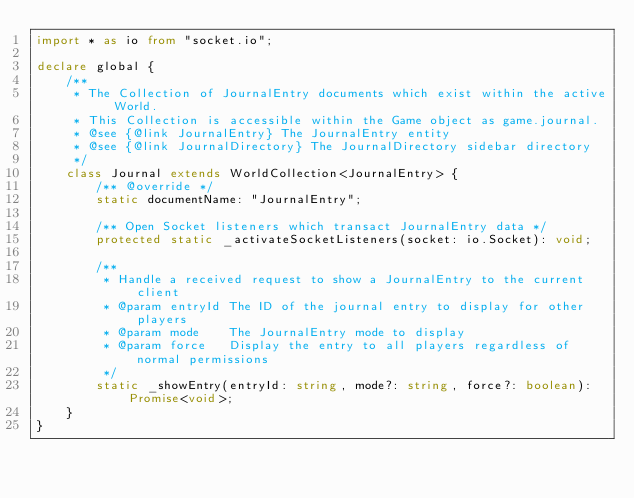<code> <loc_0><loc_0><loc_500><loc_500><_TypeScript_>import * as io from "socket.io";

declare global {
    /**
     * The Collection of JournalEntry documents which exist within the active World.
     * This Collection is accessible within the Game object as game.journal.
     * @see {@link JournalEntry} The JournalEntry entity
     * @see {@link JournalDirectory} The JournalDirectory sidebar directory
     */
    class Journal extends WorldCollection<JournalEntry> {
        /** @override */
        static documentName: "JournalEntry";

        /** Open Socket listeners which transact JournalEntry data */
        protected static _activateSocketListeners(socket: io.Socket): void;

        /**
         * Handle a received request to show a JournalEntry to the current client
         * @param entryId The ID of the journal entry to display for other players
         * @param mode    The JournalEntry mode to display
         * @param force   Display the entry to all players regardless of normal permissions
         */
        static _showEntry(entryId: string, mode?: string, force?: boolean): Promise<void>;
    }
}
</code> 